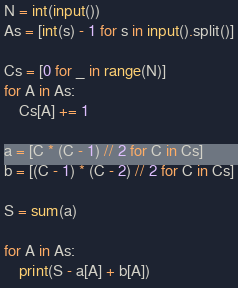<code> <loc_0><loc_0><loc_500><loc_500><_Python_>N = int(input())
As = [int(s) - 1 for s in input().split()]

Cs = [0 for _ in range(N)]
for A in As:
    Cs[A] += 1

a = [C * (C - 1) // 2 for C in Cs]
b = [(C - 1) * (C - 2) // 2 for C in Cs]

S = sum(a)

for A in As:
    print(S - a[A] + b[A])
</code> 